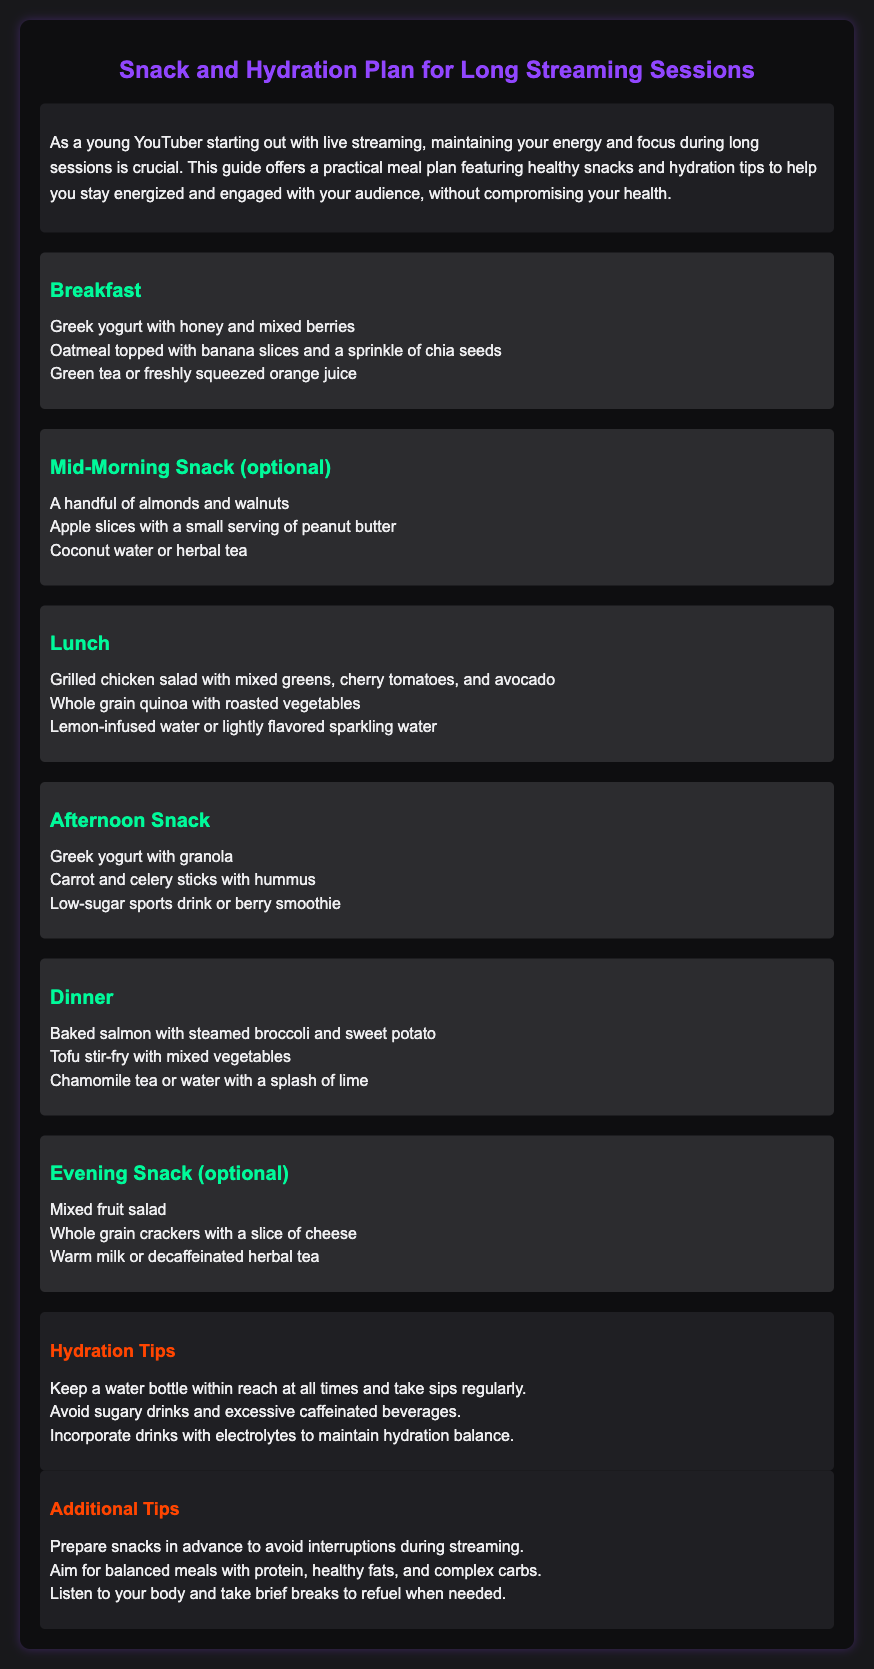What is the first meal listed in the plan? The first meal listed in the plan is Breakfast, which includes Greek yogurt with honey and mixed berries.
Answer: Greek yogurt with honey and mixed berries What is a recommended beverage for lunch? The recommended beverage for lunch is lemon-infused water or lightly flavored sparkling water.
Answer: Lemon-infused water What are two afternoon snack options? Two afternoon snack options include Greek yogurt with granola and carrot and celery sticks with hummus.
Answer: Greek yogurt with granola; carrot and celery sticks with hummus How many snacks are mentioned in the meal plan? The meal plan mentions four snacks: Mid-Morning Snack, Afternoon Snack, Evening Snack, and optional snacks.
Answer: Four What is suggested to keep hydrated during streaming? It is suggested to keep a water bottle within reach and take sips regularly to stay hydrated.
Answer: Keep a water bottle within reach What type of meal should you aim for according to additional tips? You should aim for balanced meals with protein, healthy fats, and complex carbs according to the additional tips.
Answer: Balanced meals with protein, healthy fats, and complex carbs What is one hydration tip provided in the document? One hydration tip given is to avoid sugary drinks and excessive caffeinated beverages.
Answer: Avoid sugary drinks How is the document styled? The document is styled with a dark theme and specific colors like purple for headings and teal for sub-headings.
Answer: Dark theme What should you do with snacks prior to streaming? You should prepare snacks in advance to avoid interruptions during streaming.
Answer: Prepare snacks in advance 